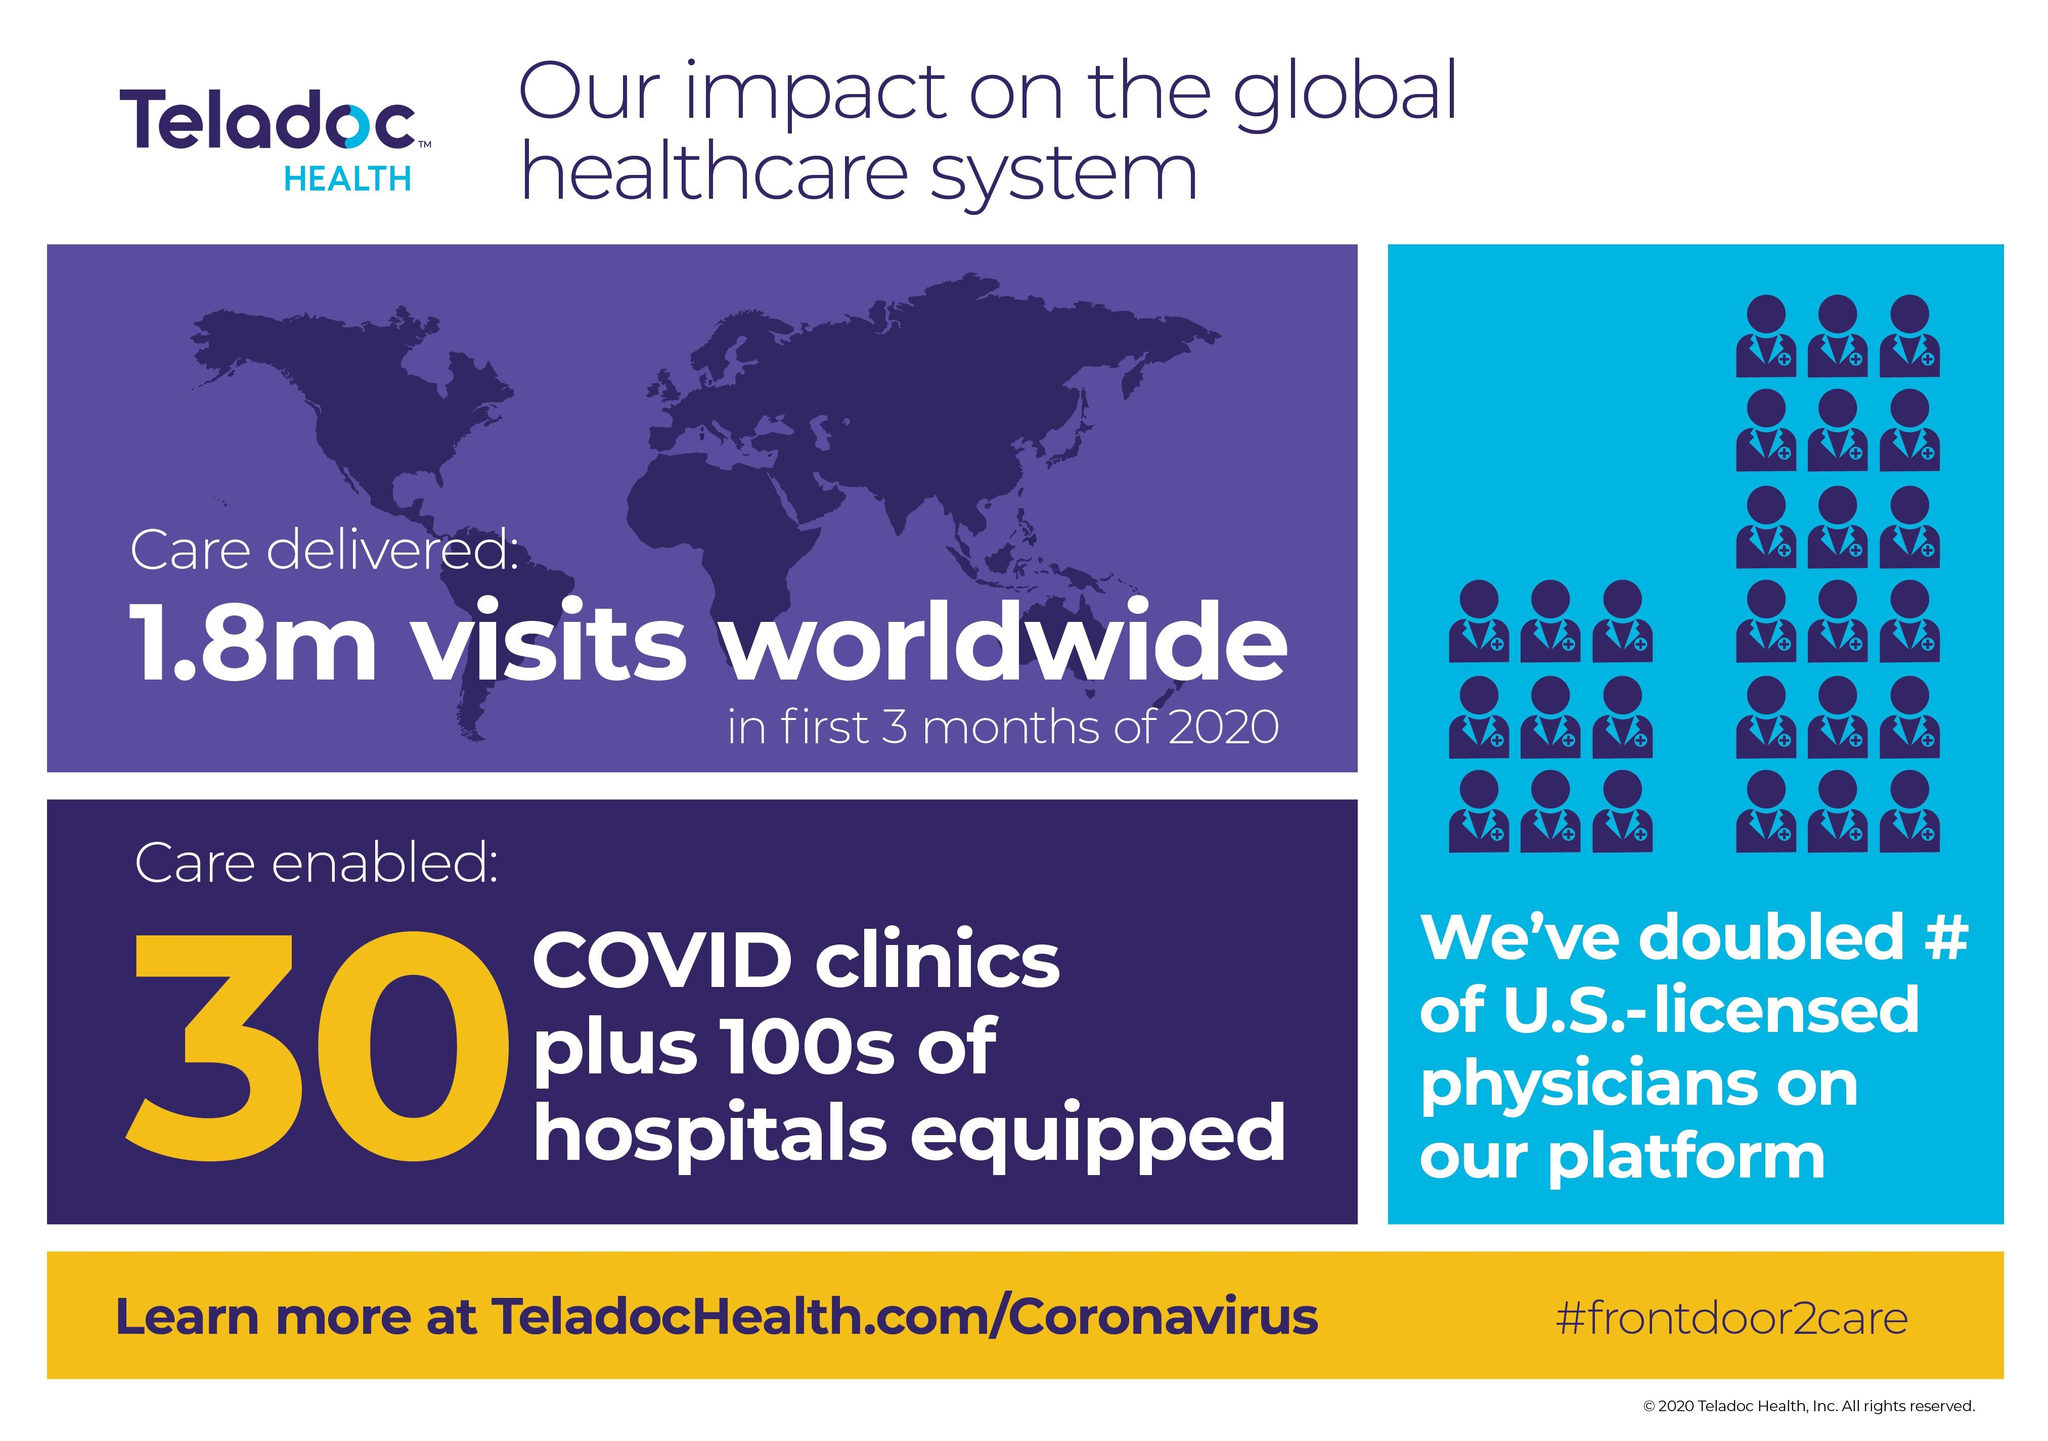Indicate a few pertinent items in this graphic. The hashtag mentioned is #frontdoor2care. The infographic displays 27 icons of people. 